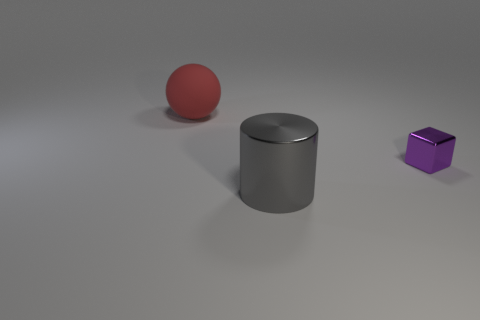Add 1 big shiny things. How many objects exist? 4 Subtract all cubes. How many objects are left? 2 Subtract 1 cylinders. How many cylinders are left? 0 Add 2 small objects. How many small objects are left? 3 Add 2 tiny cyan metal balls. How many tiny cyan metal balls exist? 2 Subtract 0 red cylinders. How many objects are left? 3 Subtract all brown balls. Subtract all gray cylinders. How many balls are left? 1 Subtract all big brown blocks. Subtract all red objects. How many objects are left? 2 